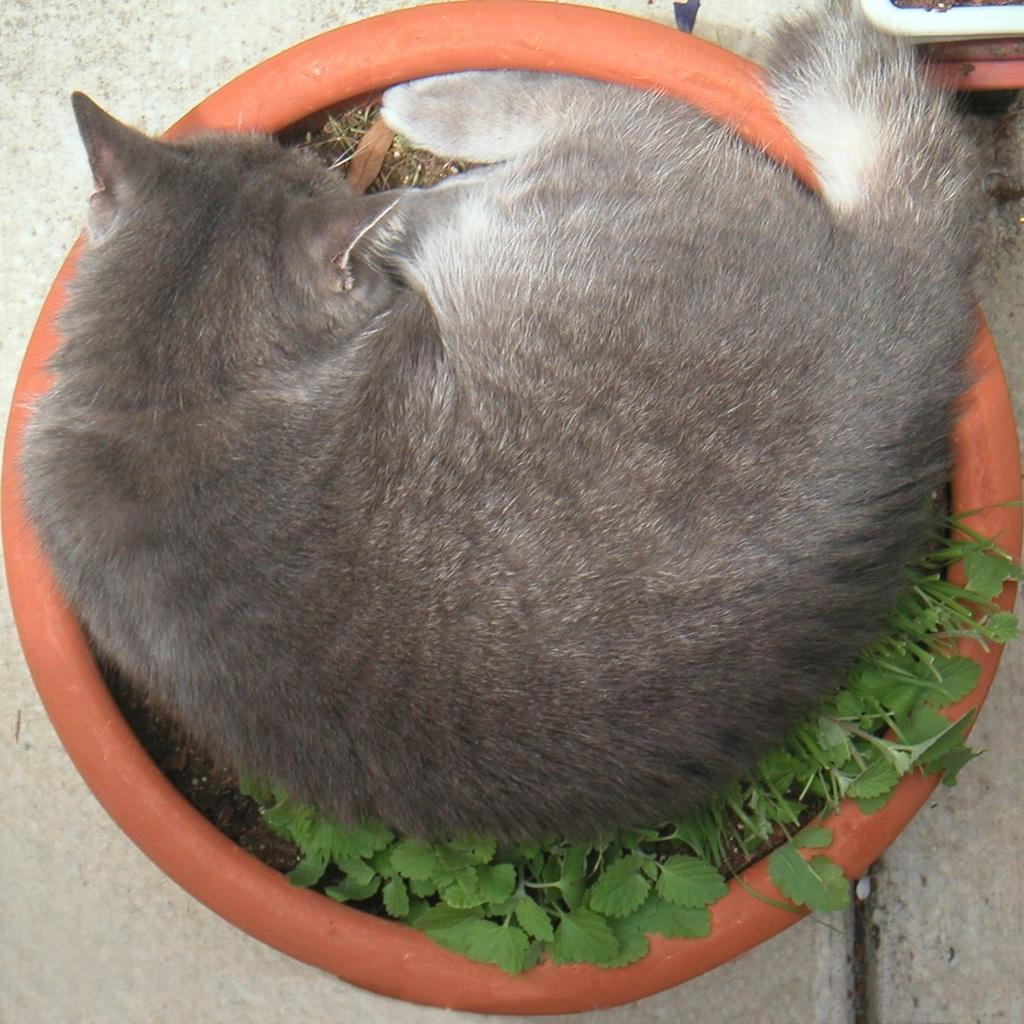What animal is present in the image? There is a cat in the image. Where is the cat located? The cat is sitting on a plant pot. What is the plant pot resting on? The plant pot is on the floor. What language is the cat speaking in the image? Cats do not speak human languages, so it is not possible to determine the language the cat is speaking in the image. 